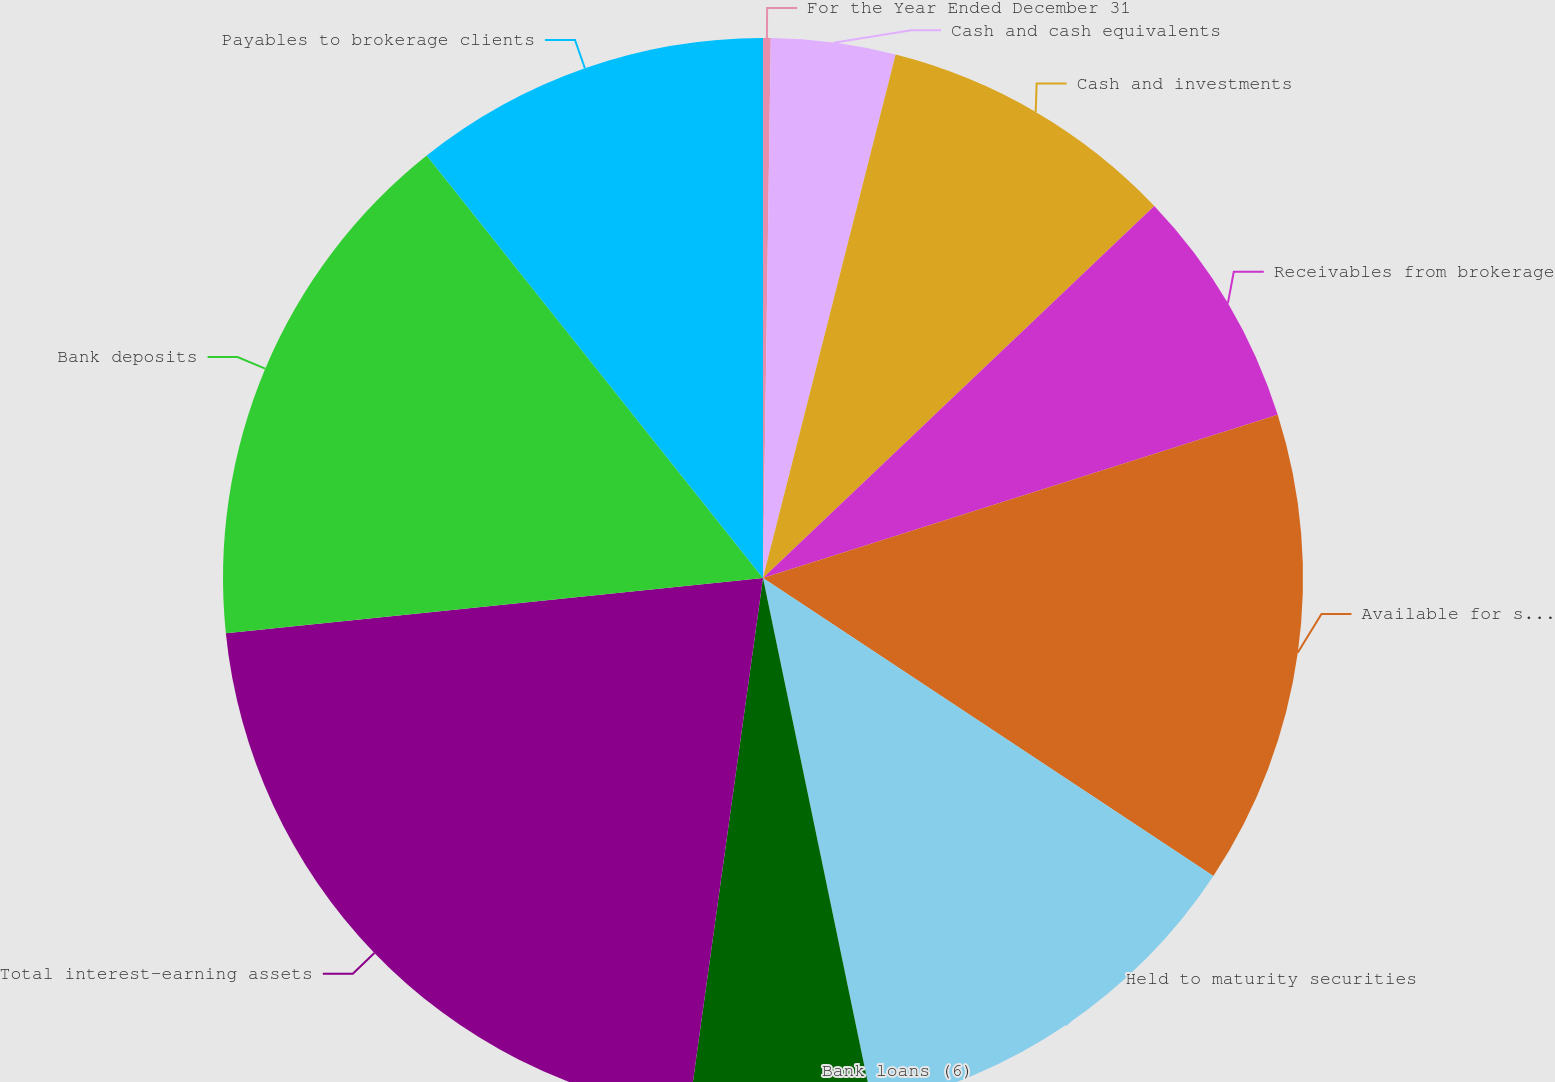Convert chart to OTSL. <chart><loc_0><loc_0><loc_500><loc_500><pie_chart><fcel>For the Year Ended December 31<fcel>Cash and cash equivalents<fcel>Cash and investments<fcel>Receivables from brokerage<fcel>Available for sale securities<fcel>Held to maturity securities<fcel>Bank loans (6)<fcel>Total interest-earning assets<fcel>Bank deposits<fcel>Payables to brokerage clients<nl><fcel>0.23%<fcel>3.72%<fcel>8.95%<fcel>7.21%<fcel>14.19%<fcel>12.44%<fcel>5.46%<fcel>21.17%<fcel>15.93%<fcel>10.7%<nl></chart> 